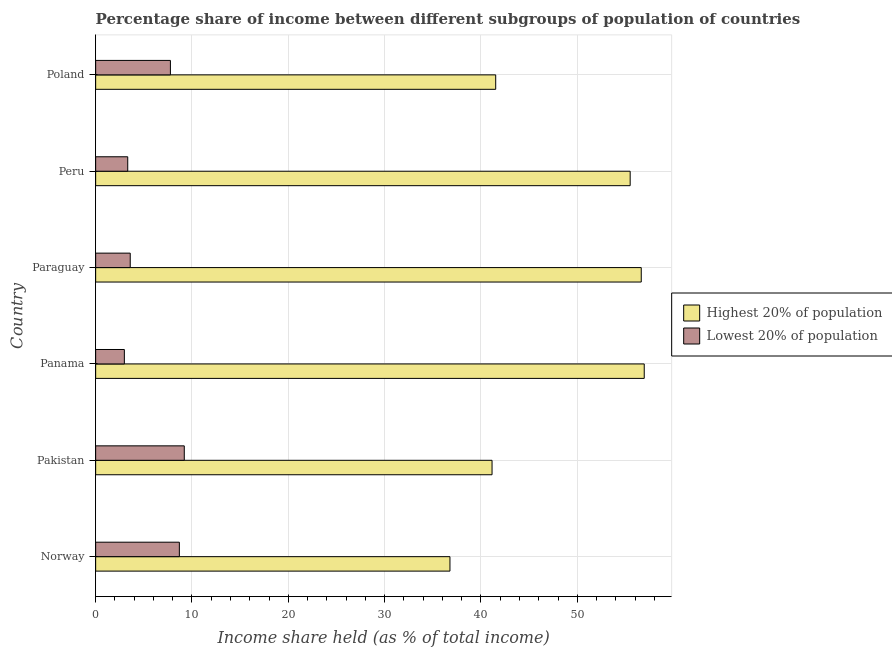How many groups of bars are there?
Make the answer very short. 6. Are the number of bars per tick equal to the number of legend labels?
Keep it short and to the point. Yes. How many bars are there on the 4th tick from the bottom?
Your answer should be very brief. 2. What is the income share held by highest 20% of the population in Poland?
Offer a very short reply. 41.53. Across all countries, what is the minimum income share held by lowest 20% of the population?
Your response must be concise. 2.98. In which country was the income share held by highest 20% of the population minimum?
Make the answer very short. Norway. What is the total income share held by highest 20% of the population in the graph?
Provide a succinct answer. 288.54. What is the difference between the income share held by lowest 20% of the population in Paraguay and that in Poland?
Your answer should be compact. -4.17. What is the difference between the income share held by lowest 20% of the population in Panama and the income share held by highest 20% of the population in Paraguay?
Give a very brief answer. -53.66. What is the average income share held by highest 20% of the population per country?
Provide a succinct answer. 48.09. What is the difference between the income share held by lowest 20% of the population and income share held by highest 20% of the population in Norway?
Ensure brevity in your answer.  -28.09. In how many countries, is the income share held by lowest 20% of the population greater than 28 %?
Your response must be concise. 0. What is the ratio of the income share held by lowest 20% of the population in Pakistan to that in Panama?
Your answer should be very brief. 3.09. Is the income share held by highest 20% of the population in Pakistan less than that in Poland?
Keep it short and to the point. Yes. What is the difference between the highest and the second highest income share held by lowest 20% of the population?
Your answer should be very brief. 0.51. What is the difference between the highest and the lowest income share held by lowest 20% of the population?
Keep it short and to the point. 6.22. In how many countries, is the income share held by highest 20% of the population greater than the average income share held by highest 20% of the population taken over all countries?
Offer a terse response. 3. What does the 1st bar from the top in Pakistan represents?
Provide a succinct answer. Lowest 20% of population. What does the 2nd bar from the bottom in Paraguay represents?
Your response must be concise. Lowest 20% of population. How many bars are there?
Provide a succinct answer. 12. How many countries are there in the graph?
Keep it short and to the point. 6. Does the graph contain grids?
Offer a very short reply. Yes. Where does the legend appear in the graph?
Offer a terse response. Center right. What is the title of the graph?
Your answer should be very brief. Percentage share of income between different subgroups of population of countries. Does "Urban" appear as one of the legend labels in the graph?
Ensure brevity in your answer.  No. What is the label or title of the X-axis?
Make the answer very short. Income share held (as % of total income). What is the Income share held (as % of total income) in Highest 20% of population in Norway?
Keep it short and to the point. 36.78. What is the Income share held (as % of total income) in Lowest 20% of population in Norway?
Your response must be concise. 8.69. What is the Income share held (as % of total income) in Highest 20% of population in Pakistan?
Provide a short and direct response. 41.15. What is the Income share held (as % of total income) of Highest 20% of population in Panama?
Provide a short and direct response. 56.95. What is the Income share held (as % of total income) in Lowest 20% of population in Panama?
Your answer should be very brief. 2.98. What is the Income share held (as % of total income) in Highest 20% of population in Paraguay?
Give a very brief answer. 56.64. What is the Income share held (as % of total income) in Lowest 20% of population in Paraguay?
Provide a short and direct response. 3.59. What is the Income share held (as % of total income) in Highest 20% of population in Peru?
Your response must be concise. 55.49. What is the Income share held (as % of total income) of Lowest 20% of population in Peru?
Your response must be concise. 3.33. What is the Income share held (as % of total income) of Highest 20% of population in Poland?
Make the answer very short. 41.53. What is the Income share held (as % of total income) of Lowest 20% of population in Poland?
Your answer should be very brief. 7.76. Across all countries, what is the maximum Income share held (as % of total income) of Highest 20% of population?
Your answer should be very brief. 56.95. Across all countries, what is the minimum Income share held (as % of total income) in Highest 20% of population?
Offer a very short reply. 36.78. Across all countries, what is the minimum Income share held (as % of total income) in Lowest 20% of population?
Provide a succinct answer. 2.98. What is the total Income share held (as % of total income) of Highest 20% of population in the graph?
Keep it short and to the point. 288.54. What is the total Income share held (as % of total income) in Lowest 20% of population in the graph?
Your answer should be very brief. 35.55. What is the difference between the Income share held (as % of total income) of Highest 20% of population in Norway and that in Pakistan?
Your answer should be compact. -4.37. What is the difference between the Income share held (as % of total income) in Lowest 20% of population in Norway and that in Pakistan?
Ensure brevity in your answer.  -0.51. What is the difference between the Income share held (as % of total income) in Highest 20% of population in Norway and that in Panama?
Provide a succinct answer. -20.17. What is the difference between the Income share held (as % of total income) of Lowest 20% of population in Norway and that in Panama?
Give a very brief answer. 5.71. What is the difference between the Income share held (as % of total income) in Highest 20% of population in Norway and that in Paraguay?
Keep it short and to the point. -19.86. What is the difference between the Income share held (as % of total income) of Lowest 20% of population in Norway and that in Paraguay?
Ensure brevity in your answer.  5.1. What is the difference between the Income share held (as % of total income) of Highest 20% of population in Norway and that in Peru?
Your response must be concise. -18.71. What is the difference between the Income share held (as % of total income) in Lowest 20% of population in Norway and that in Peru?
Keep it short and to the point. 5.36. What is the difference between the Income share held (as % of total income) of Highest 20% of population in Norway and that in Poland?
Your answer should be compact. -4.75. What is the difference between the Income share held (as % of total income) in Lowest 20% of population in Norway and that in Poland?
Provide a short and direct response. 0.93. What is the difference between the Income share held (as % of total income) in Highest 20% of population in Pakistan and that in Panama?
Offer a terse response. -15.8. What is the difference between the Income share held (as % of total income) in Lowest 20% of population in Pakistan and that in Panama?
Provide a succinct answer. 6.22. What is the difference between the Income share held (as % of total income) in Highest 20% of population in Pakistan and that in Paraguay?
Keep it short and to the point. -15.49. What is the difference between the Income share held (as % of total income) in Lowest 20% of population in Pakistan and that in Paraguay?
Provide a succinct answer. 5.61. What is the difference between the Income share held (as % of total income) in Highest 20% of population in Pakistan and that in Peru?
Offer a terse response. -14.34. What is the difference between the Income share held (as % of total income) in Lowest 20% of population in Pakistan and that in Peru?
Keep it short and to the point. 5.87. What is the difference between the Income share held (as % of total income) in Highest 20% of population in Pakistan and that in Poland?
Provide a succinct answer. -0.38. What is the difference between the Income share held (as % of total income) in Lowest 20% of population in Pakistan and that in Poland?
Make the answer very short. 1.44. What is the difference between the Income share held (as % of total income) of Highest 20% of population in Panama and that in Paraguay?
Your answer should be compact. 0.31. What is the difference between the Income share held (as % of total income) in Lowest 20% of population in Panama and that in Paraguay?
Your answer should be compact. -0.61. What is the difference between the Income share held (as % of total income) in Highest 20% of population in Panama and that in Peru?
Keep it short and to the point. 1.46. What is the difference between the Income share held (as % of total income) of Lowest 20% of population in Panama and that in Peru?
Offer a very short reply. -0.35. What is the difference between the Income share held (as % of total income) of Highest 20% of population in Panama and that in Poland?
Your answer should be compact. 15.42. What is the difference between the Income share held (as % of total income) in Lowest 20% of population in Panama and that in Poland?
Your answer should be very brief. -4.78. What is the difference between the Income share held (as % of total income) in Highest 20% of population in Paraguay and that in Peru?
Ensure brevity in your answer.  1.15. What is the difference between the Income share held (as % of total income) of Lowest 20% of population in Paraguay and that in Peru?
Your answer should be compact. 0.26. What is the difference between the Income share held (as % of total income) of Highest 20% of population in Paraguay and that in Poland?
Your answer should be very brief. 15.11. What is the difference between the Income share held (as % of total income) of Lowest 20% of population in Paraguay and that in Poland?
Your answer should be very brief. -4.17. What is the difference between the Income share held (as % of total income) of Highest 20% of population in Peru and that in Poland?
Ensure brevity in your answer.  13.96. What is the difference between the Income share held (as % of total income) of Lowest 20% of population in Peru and that in Poland?
Make the answer very short. -4.43. What is the difference between the Income share held (as % of total income) of Highest 20% of population in Norway and the Income share held (as % of total income) of Lowest 20% of population in Pakistan?
Give a very brief answer. 27.58. What is the difference between the Income share held (as % of total income) of Highest 20% of population in Norway and the Income share held (as % of total income) of Lowest 20% of population in Panama?
Provide a succinct answer. 33.8. What is the difference between the Income share held (as % of total income) of Highest 20% of population in Norway and the Income share held (as % of total income) of Lowest 20% of population in Paraguay?
Provide a succinct answer. 33.19. What is the difference between the Income share held (as % of total income) of Highest 20% of population in Norway and the Income share held (as % of total income) of Lowest 20% of population in Peru?
Your response must be concise. 33.45. What is the difference between the Income share held (as % of total income) of Highest 20% of population in Norway and the Income share held (as % of total income) of Lowest 20% of population in Poland?
Offer a terse response. 29.02. What is the difference between the Income share held (as % of total income) of Highest 20% of population in Pakistan and the Income share held (as % of total income) of Lowest 20% of population in Panama?
Ensure brevity in your answer.  38.17. What is the difference between the Income share held (as % of total income) of Highest 20% of population in Pakistan and the Income share held (as % of total income) of Lowest 20% of population in Paraguay?
Give a very brief answer. 37.56. What is the difference between the Income share held (as % of total income) in Highest 20% of population in Pakistan and the Income share held (as % of total income) in Lowest 20% of population in Peru?
Your answer should be compact. 37.82. What is the difference between the Income share held (as % of total income) in Highest 20% of population in Pakistan and the Income share held (as % of total income) in Lowest 20% of population in Poland?
Give a very brief answer. 33.39. What is the difference between the Income share held (as % of total income) in Highest 20% of population in Panama and the Income share held (as % of total income) in Lowest 20% of population in Paraguay?
Ensure brevity in your answer.  53.36. What is the difference between the Income share held (as % of total income) of Highest 20% of population in Panama and the Income share held (as % of total income) of Lowest 20% of population in Peru?
Offer a very short reply. 53.62. What is the difference between the Income share held (as % of total income) of Highest 20% of population in Panama and the Income share held (as % of total income) of Lowest 20% of population in Poland?
Your response must be concise. 49.19. What is the difference between the Income share held (as % of total income) in Highest 20% of population in Paraguay and the Income share held (as % of total income) in Lowest 20% of population in Peru?
Provide a succinct answer. 53.31. What is the difference between the Income share held (as % of total income) in Highest 20% of population in Paraguay and the Income share held (as % of total income) in Lowest 20% of population in Poland?
Ensure brevity in your answer.  48.88. What is the difference between the Income share held (as % of total income) of Highest 20% of population in Peru and the Income share held (as % of total income) of Lowest 20% of population in Poland?
Offer a very short reply. 47.73. What is the average Income share held (as % of total income) in Highest 20% of population per country?
Your answer should be very brief. 48.09. What is the average Income share held (as % of total income) in Lowest 20% of population per country?
Your answer should be very brief. 5.92. What is the difference between the Income share held (as % of total income) of Highest 20% of population and Income share held (as % of total income) of Lowest 20% of population in Norway?
Provide a short and direct response. 28.09. What is the difference between the Income share held (as % of total income) of Highest 20% of population and Income share held (as % of total income) of Lowest 20% of population in Pakistan?
Provide a short and direct response. 31.95. What is the difference between the Income share held (as % of total income) in Highest 20% of population and Income share held (as % of total income) in Lowest 20% of population in Panama?
Your answer should be compact. 53.97. What is the difference between the Income share held (as % of total income) of Highest 20% of population and Income share held (as % of total income) of Lowest 20% of population in Paraguay?
Your answer should be very brief. 53.05. What is the difference between the Income share held (as % of total income) of Highest 20% of population and Income share held (as % of total income) of Lowest 20% of population in Peru?
Your answer should be compact. 52.16. What is the difference between the Income share held (as % of total income) of Highest 20% of population and Income share held (as % of total income) of Lowest 20% of population in Poland?
Provide a succinct answer. 33.77. What is the ratio of the Income share held (as % of total income) of Highest 20% of population in Norway to that in Pakistan?
Give a very brief answer. 0.89. What is the ratio of the Income share held (as % of total income) in Lowest 20% of population in Norway to that in Pakistan?
Ensure brevity in your answer.  0.94. What is the ratio of the Income share held (as % of total income) in Highest 20% of population in Norway to that in Panama?
Keep it short and to the point. 0.65. What is the ratio of the Income share held (as % of total income) of Lowest 20% of population in Norway to that in Panama?
Keep it short and to the point. 2.92. What is the ratio of the Income share held (as % of total income) in Highest 20% of population in Norway to that in Paraguay?
Offer a terse response. 0.65. What is the ratio of the Income share held (as % of total income) in Lowest 20% of population in Norway to that in Paraguay?
Give a very brief answer. 2.42. What is the ratio of the Income share held (as % of total income) of Highest 20% of population in Norway to that in Peru?
Your answer should be compact. 0.66. What is the ratio of the Income share held (as % of total income) in Lowest 20% of population in Norway to that in Peru?
Your response must be concise. 2.61. What is the ratio of the Income share held (as % of total income) in Highest 20% of population in Norway to that in Poland?
Your response must be concise. 0.89. What is the ratio of the Income share held (as % of total income) in Lowest 20% of population in Norway to that in Poland?
Make the answer very short. 1.12. What is the ratio of the Income share held (as % of total income) in Highest 20% of population in Pakistan to that in Panama?
Provide a succinct answer. 0.72. What is the ratio of the Income share held (as % of total income) of Lowest 20% of population in Pakistan to that in Panama?
Make the answer very short. 3.09. What is the ratio of the Income share held (as % of total income) in Highest 20% of population in Pakistan to that in Paraguay?
Your answer should be compact. 0.73. What is the ratio of the Income share held (as % of total income) of Lowest 20% of population in Pakistan to that in Paraguay?
Make the answer very short. 2.56. What is the ratio of the Income share held (as % of total income) in Highest 20% of population in Pakistan to that in Peru?
Give a very brief answer. 0.74. What is the ratio of the Income share held (as % of total income) of Lowest 20% of population in Pakistan to that in Peru?
Offer a terse response. 2.76. What is the ratio of the Income share held (as % of total income) of Lowest 20% of population in Pakistan to that in Poland?
Keep it short and to the point. 1.19. What is the ratio of the Income share held (as % of total income) of Lowest 20% of population in Panama to that in Paraguay?
Your response must be concise. 0.83. What is the ratio of the Income share held (as % of total income) in Highest 20% of population in Panama to that in Peru?
Make the answer very short. 1.03. What is the ratio of the Income share held (as % of total income) of Lowest 20% of population in Panama to that in Peru?
Your response must be concise. 0.89. What is the ratio of the Income share held (as % of total income) of Highest 20% of population in Panama to that in Poland?
Ensure brevity in your answer.  1.37. What is the ratio of the Income share held (as % of total income) of Lowest 20% of population in Panama to that in Poland?
Your response must be concise. 0.38. What is the ratio of the Income share held (as % of total income) in Highest 20% of population in Paraguay to that in Peru?
Ensure brevity in your answer.  1.02. What is the ratio of the Income share held (as % of total income) in Lowest 20% of population in Paraguay to that in Peru?
Ensure brevity in your answer.  1.08. What is the ratio of the Income share held (as % of total income) of Highest 20% of population in Paraguay to that in Poland?
Your answer should be very brief. 1.36. What is the ratio of the Income share held (as % of total income) in Lowest 20% of population in Paraguay to that in Poland?
Your answer should be very brief. 0.46. What is the ratio of the Income share held (as % of total income) in Highest 20% of population in Peru to that in Poland?
Your response must be concise. 1.34. What is the ratio of the Income share held (as % of total income) in Lowest 20% of population in Peru to that in Poland?
Your answer should be very brief. 0.43. What is the difference between the highest and the second highest Income share held (as % of total income) in Highest 20% of population?
Provide a succinct answer. 0.31. What is the difference between the highest and the second highest Income share held (as % of total income) of Lowest 20% of population?
Offer a very short reply. 0.51. What is the difference between the highest and the lowest Income share held (as % of total income) in Highest 20% of population?
Offer a very short reply. 20.17. What is the difference between the highest and the lowest Income share held (as % of total income) in Lowest 20% of population?
Your answer should be very brief. 6.22. 